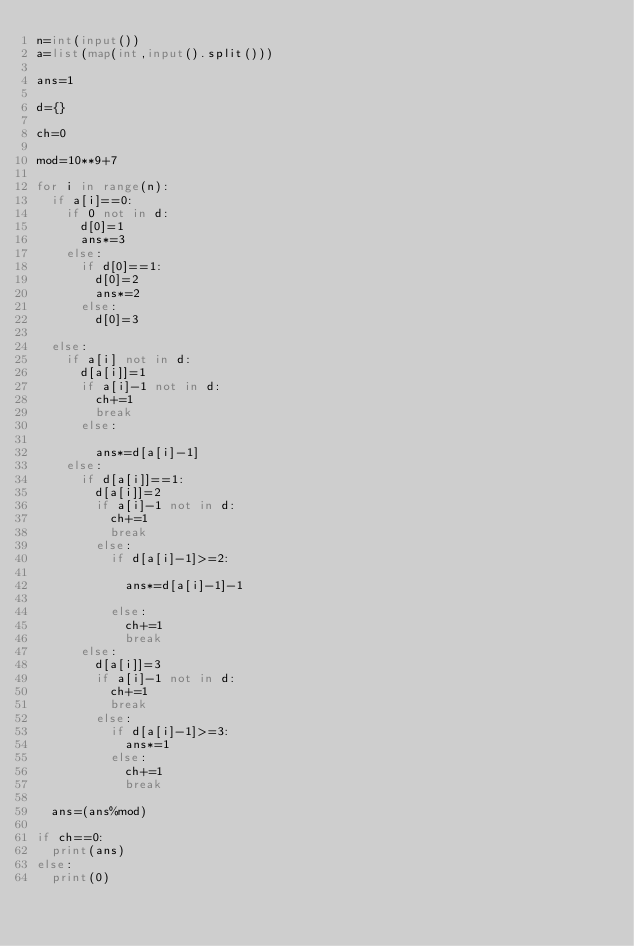Convert code to text. <code><loc_0><loc_0><loc_500><loc_500><_Python_>n=int(input())
a=list(map(int,input().split()))

ans=1

d={}

ch=0

mod=10**9+7

for i in range(n):
  if a[i]==0:
    if 0 not in d:
      d[0]=1
      ans*=3
    else:
      if d[0]==1:
        d[0]=2
        ans*=2
      else:
        d[0]=3
      
  else:
    if a[i] not in d:
      d[a[i]]=1
      if a[i]-1 not in d:
        ch+=1
        break
      else:
        
        ans*=d[a[i]-1]
    else:
      if d[a[i]]==1:
        d[a[i]]=2
        if a[i]-1 not in d:
          ch+=1
          break
        else:
          if d[a[i]-1]>=2:
            
            ans*=d[a[i]-1]-1
            
          else:
            ch+=1
            break
      else:
        d[a[i]]=3
        if a[i]-1 not in d:
          ch+=1
          break
        else:
          if d[a[i]-1]>=3:
            ans*=1
          else:
            ch+=1
            break
        
  ans=(ans%mod)
  
if ch==0:
  print(ans)
else:
  print(0)

</code> 